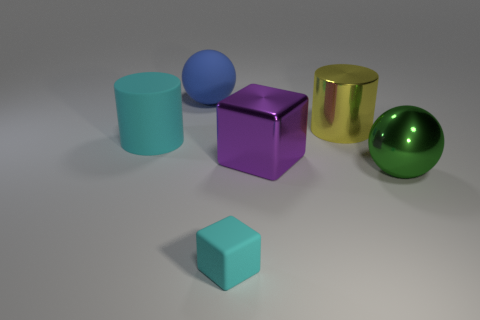Add 2 big rubber balls. How many objects exist? 8 Subtract all balls. How many objects are left? 4 Add 1 yellow shiny cylinders. How many yellow shiny cylinders are left? 2 Add 4 big blue spheres. How many big blue spheres exist? 5 Subtract 0 red blocks. How many objects are left? 6 Subtract all large matte cylinders. Subtract all cylinders. How many objects are left? 3 